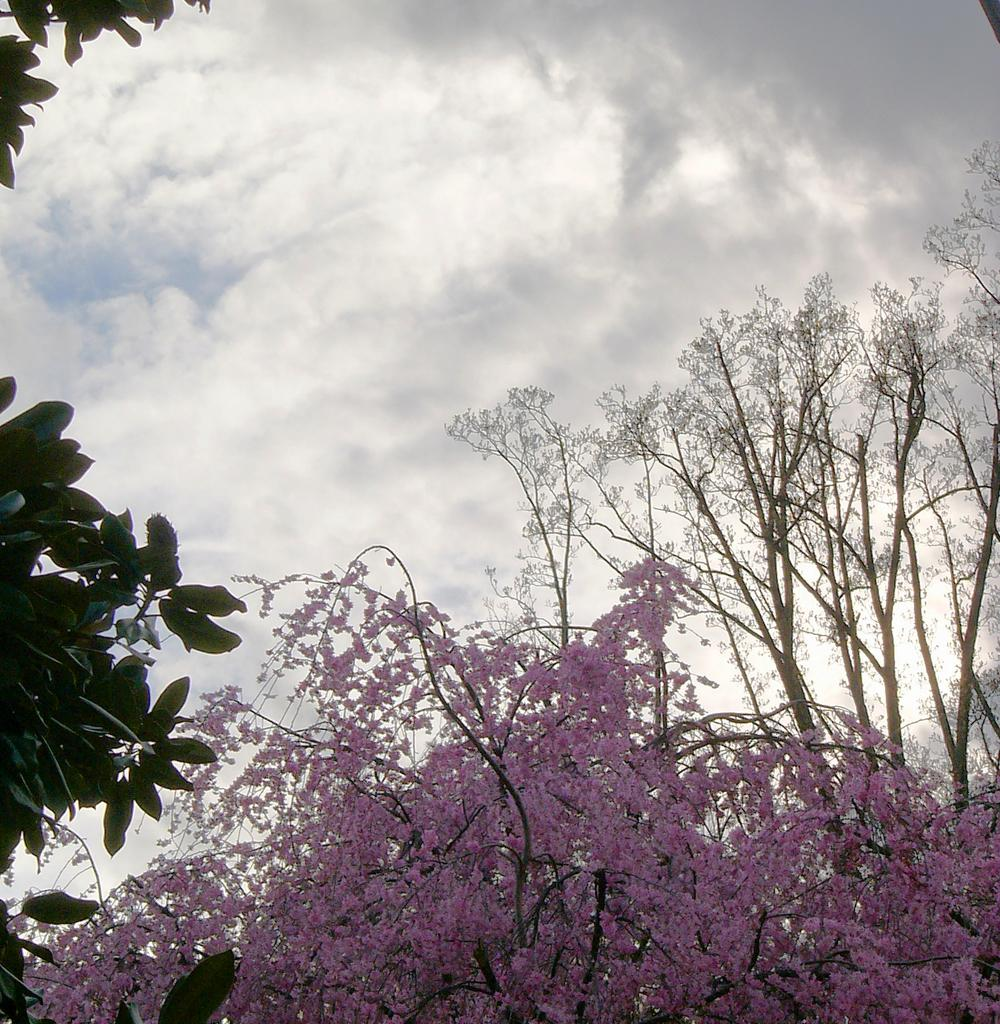What type of tree is featured in the image? There is a tree with pink flowers in the image. Are there any other trees present in the image? Yes, there are other trees in the image. What can be seen in the background of the image? The sky is visible in the background of the image. How many steel accounts are visible in the image? There is no mention of steel or accounts in the image; it features trees with pink flowers and other trees. 